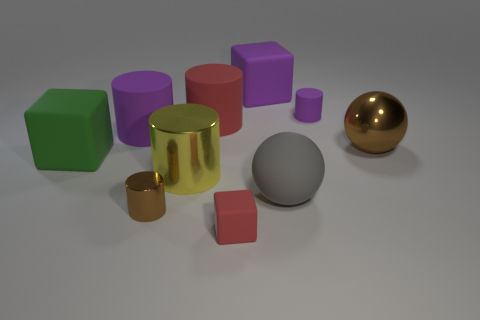There is a small matte object in front of the big metal sphere; is its color the same as the big rubber block behind the large green block?
Your response must be concise. No. Is the number of large brown metal spheres greater than the number of balls?
Keep it short and to the point. No. What number of tiny cylinders are the same color as the tiny cube?
Your answer should be very brief. 0. There is a big shiny object that is the same shape as the small brown object; what is its color?
Provide a short and direct response. Yellow. There is a large thing that is in front of the green thing and left of the big purple rubber cube; what material is it made of?
Your answer should be very brief. Metal. Does the red thing behind the brown ball have the same material as the small cylinder that is in front of the large gray rubber ball?
Your answer should be very brief. No. The brown sphere has what size?
Provide a succinct answer. Large. What is the size of the yellow thing that is the same shape as the big red matte thing?
Provide a short and direct response. Large. What number of big purple matte cylinders are on the left side of the gray thing?
Provide a succinct answer. 1. The sphere that is to the right of the cylinder that is right of the big purple rubber block is what color?
Provide a short and direct response. Brown. 